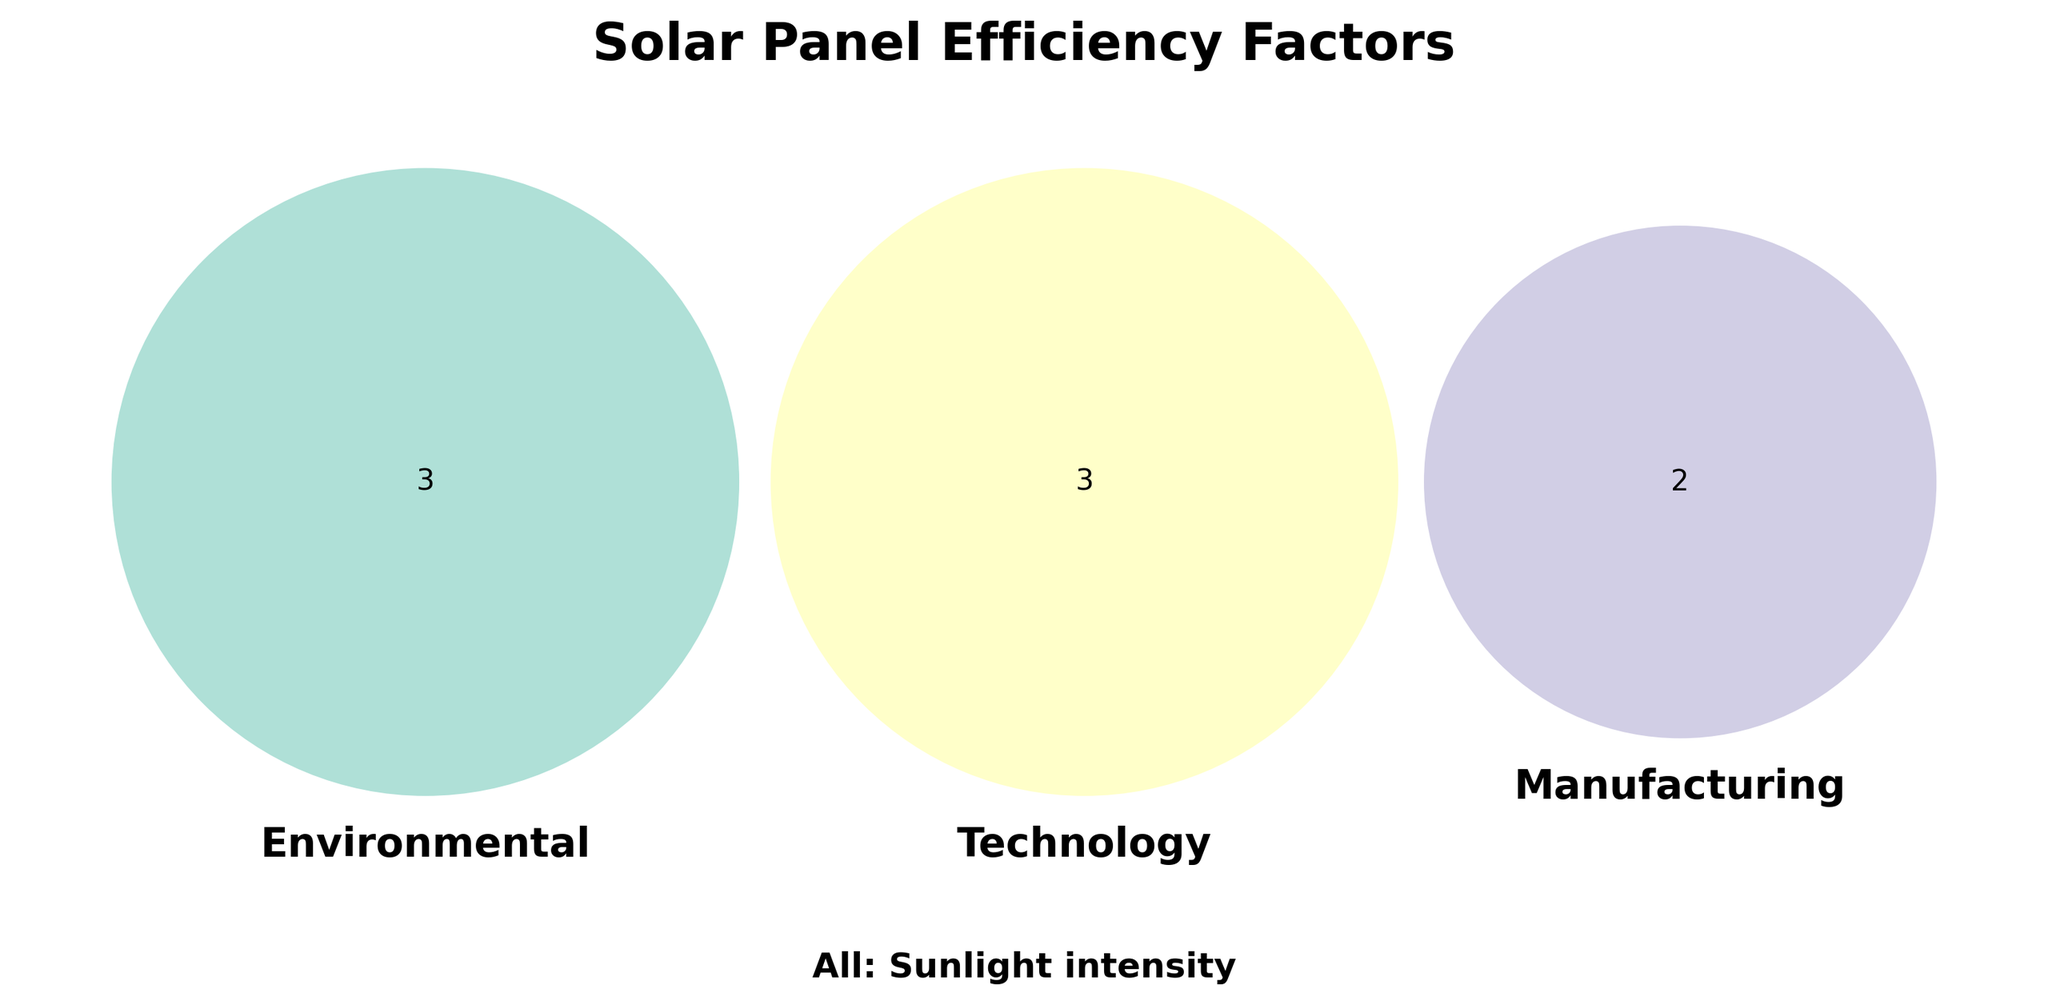What is the title of the figure? The title is written at the top of the Venn diagram. It typically describes the main topic or focus of the figure.
Answer: Solar Panel Efficiency Factors What color is used for the 'Environmental' category set in the Venn diagram? The 'Environmental' set is represented by a specific color in the Venn diagram.
Answer: A shade of green (#8dd3c7) How many environmental factors are shown in the diagram? Count the number of factors listed in the 'Environmental' category set.
Answer: 3 Which factor appears in all three categories? Identify the common factor that appears in 'Environmental', 'Technology', and 'Manufacturing' sets.
Answer: Sunlight intensity What factors fall under the 'Technology' category? List all the factors present within the 'Technology' set, distinguished by the yellow color.
Answer: Cell type, Anti-reflective coating, Inverter efficiency Are there more factors in the 'Environmental' or 'Manufacturing' category? Compare the number of factors in both the 'Environmental' and 'Manufacturing' sets to see which has more.
Answer: Environmental Which category has 'Material purity' as a factor? Find and identify the category set that includes 'Material purity'.
Answer: Manufacturing What combination of categories does 'Shading' fall into? Determine the overlap or unique set that 'Shading' belongs to.
Answer: Environmental only Which factor(s) overlap between 'Environmental' and 'Technology' sets, if any? Look at the intersection between 'Environmental' and 'Technology' sets to see if there are common factors.
Answer: None What are the shared factors between 'Technology' and 'Manufacturing'? Identify any common factors that appear in both the 'Technology' and 'Manufacturing' sets.
Answer: None 